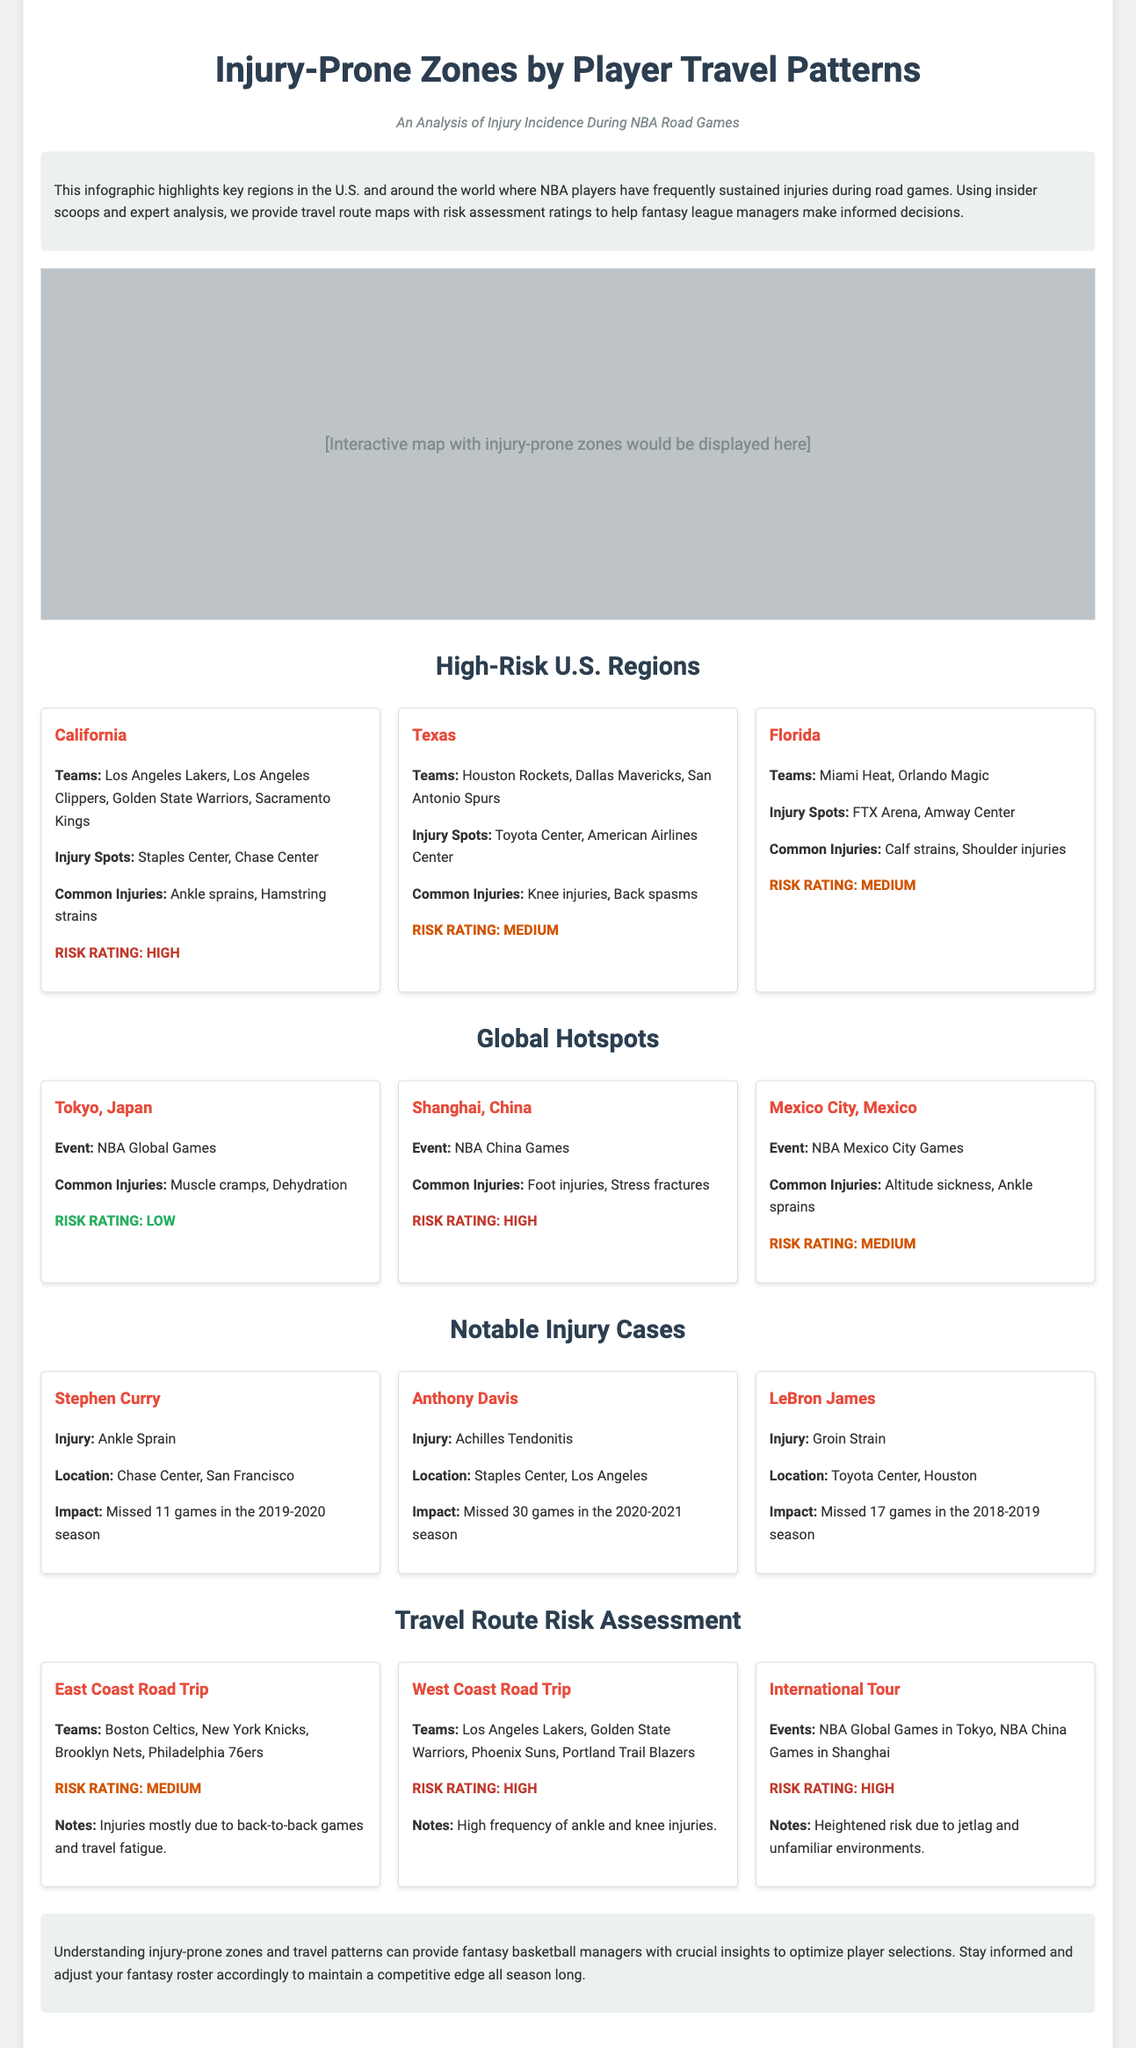What is the title of the infographic? The title is prominently displayed at the top of the document and reads "Injury-Prone Zones by Player Travel Patterns."
Answer: Injury-Prone Zones by Player Travel Patterns Which region has the highest risk rating? The region with the highest risk rating is mentioned in the high-risk U.S. regions and is labeled as "California."
Answer: California What common injury is noted for players in Texas? The infographic lists "Knee injuries" as a common injury for players in Texas.
Answer: Knee injuries How many games did Stephen Curry miss due to his ankle sprain? The impact of Stephen Curry's injury is detailed, indicating that he missed 11 games in the 2019-2020 season.
Answer: 11 games What is the risk rating for the International Tour travel route? The travel route risk assessment includes a rating for the International Tour which is mentioned as "High."
Answer: High Which city is noted for the NBA Global Games? The infographic specifies "Tokyo, Japan" as the city noted for the NBA Global Games.
Answer: Tokyo, Japan What type of injuries are common in Shanghai during NBA China Games? The document highlights "Foot injuries" as common injuries in Shanghai during the NBA China Games.
Answer: Foot injuries Which team is associated with the injury-prone zone in Florida? The list in the Florida section includes the "Miami Heat" as an associated team.
Answer: Miami Heat What is the common injury noted for players during the West Coast Road Trip? The document specifies "ankle and knee injuries" as common injuries during the West Coast Road Trip.
Answer: ankle and knee injuries 